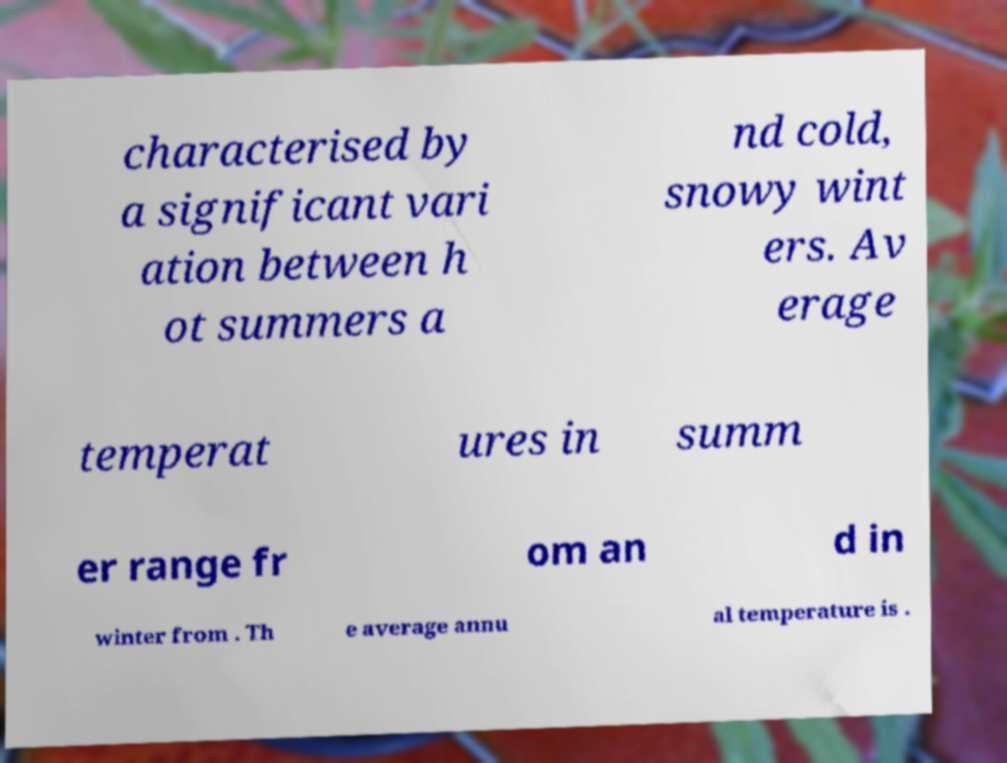Please identify and transcribe the text found in this image. characterised by a significant vari ation between h ot summers a nd cold, snowy wint ers. Av erage temperat ures in summ er range fr om an d in winter from . Th e average annu al temperature is . 